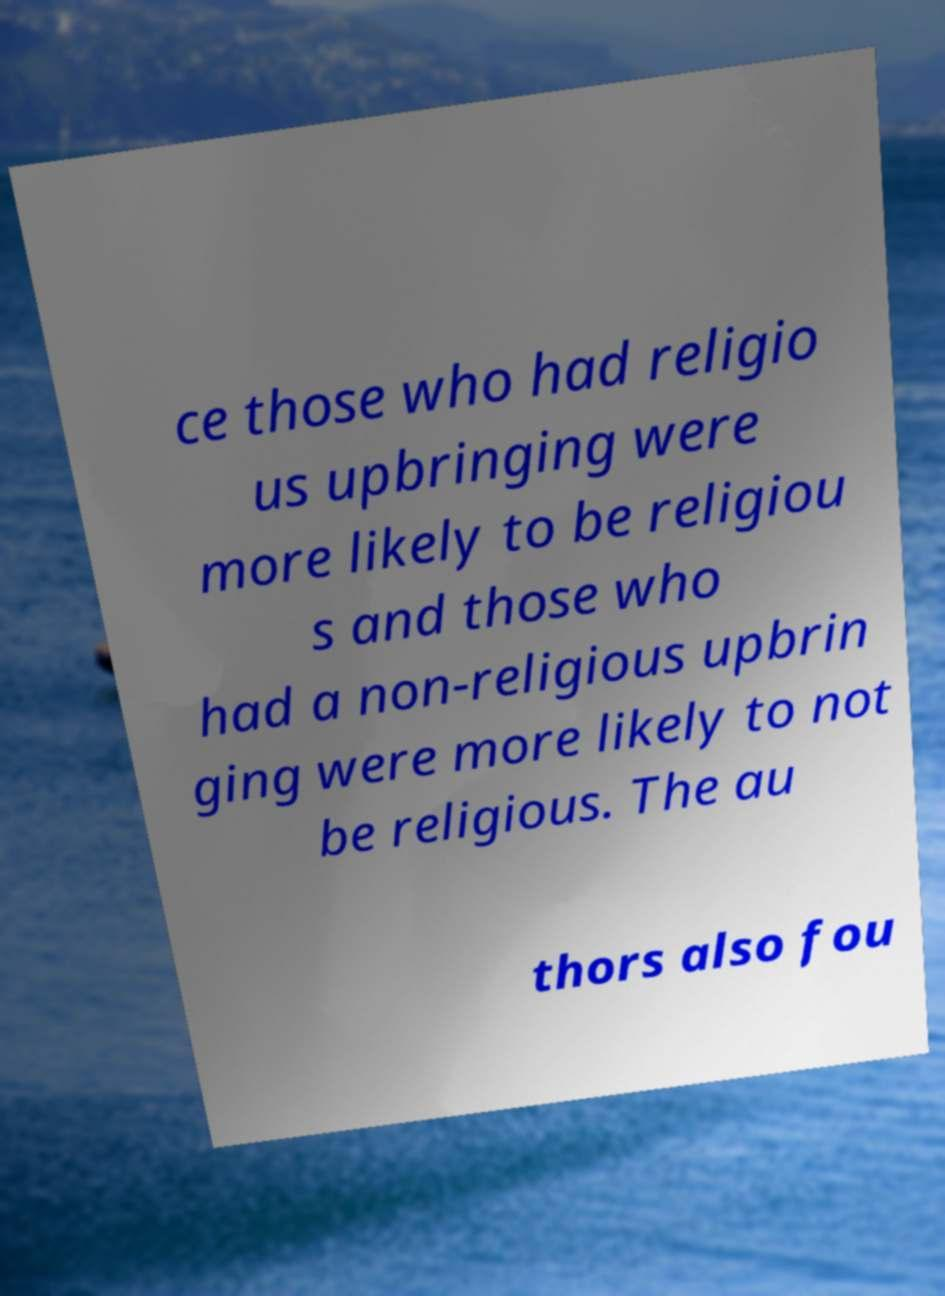For documentation purposes, I need the text within this image transcribed. Could you provide that? ce those who had religio us upbringing were more likely to be religiou s and those who had a non-religious upbrin ging were more likely to not be religious. The au thors also fou 